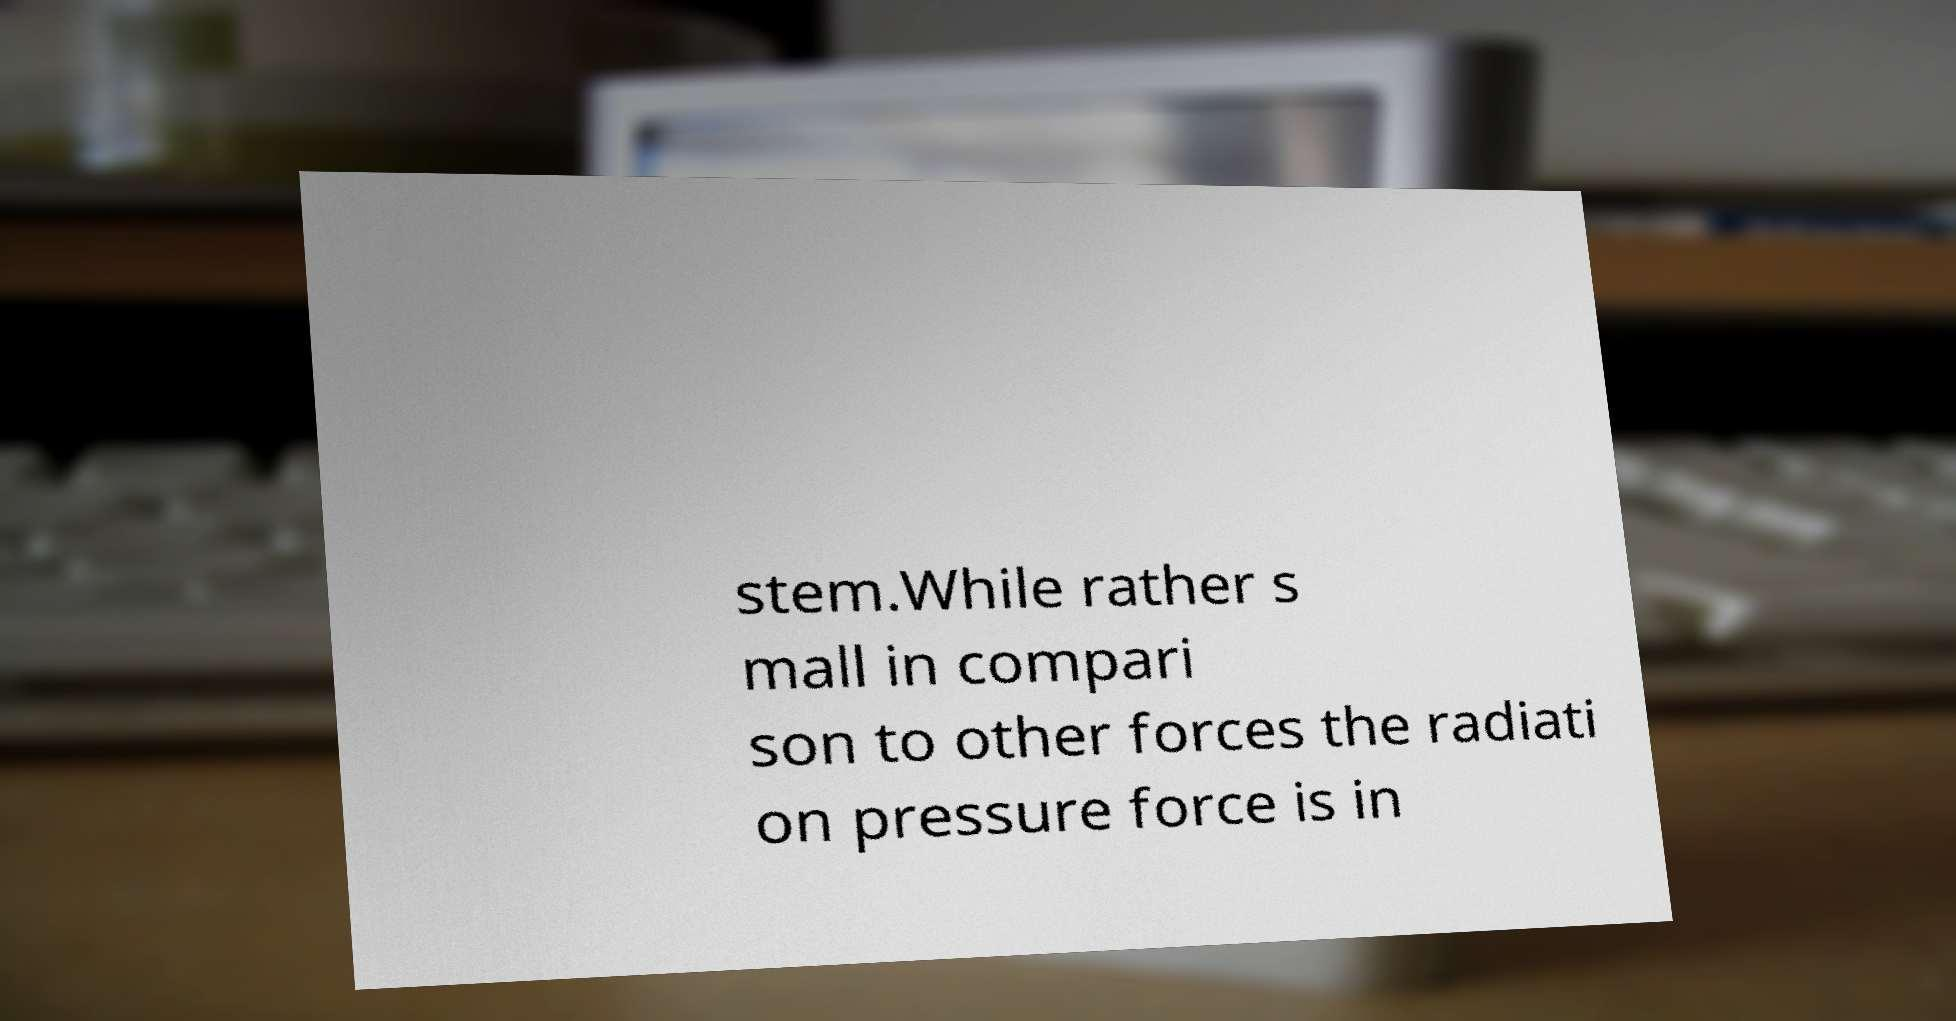I need the written content from this picture converted into text. Can you do that? stem.While rather s mall in compari son to other forces the radiati on pressure force is in 